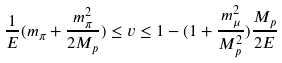<formula> <loc_0><loc_0><loc_500><loc_500>\frac { 1 } { E } ( m _ { \pi } + \frac { m _ { \pi } ^ { 2 } } { 2 M _ { p } } ) \leq v \leq 1 - ( 1 + \frac { m _ { \mu } ^ { 2 } } { M _ { p } ^ { 2 } } ) \frac { M _ { p } } { 2 E }</formula> 